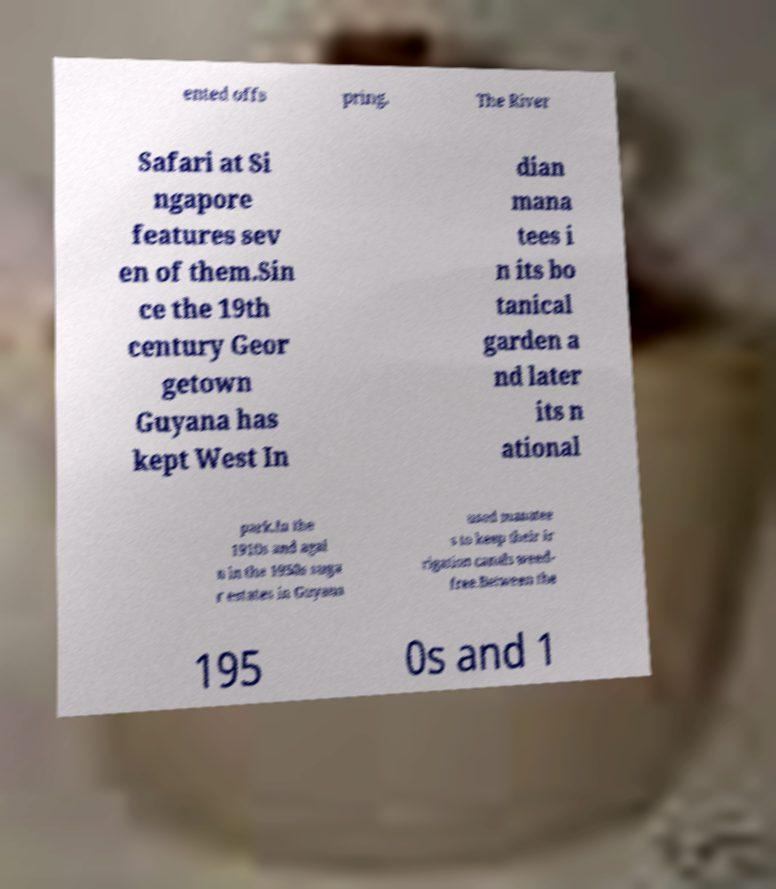Please identify and transcribe the text found in this image. ented offs pring. The River Safari at Si ngapore features sev en of them.Sin ce the 19th century Geor getown Guyana has kept West In dian mana tees i n its bo tanical garden a nd later its n ational park.In the 1910s and agai n in the 1950s suga r estates in Guyana used manatee s to keep their ir rigation canals weed- free.Between the 195 0s and 1 